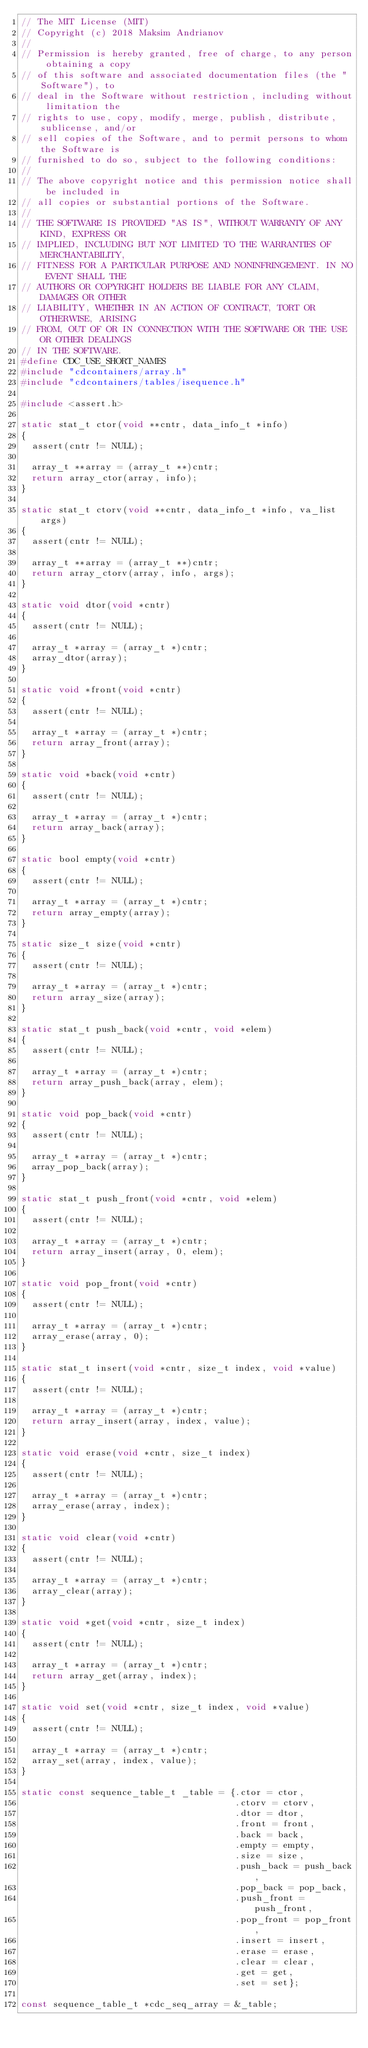Convert code to text. <code><loc_0><loc_0><loc_500><loc_500><_C_>// The MIT License (MIT)
// Copyright (c) 2018 Maksim Andrianov
//
// Permission is hereby granted, free of charge, to any person obtaining a copy
// of this software and associated documentation files (the "Software"), to
// deal in the Software without restriction, including without limitation the
// rights to use, copy, modify, merge, publish, distribute, sublicense, and/or
// sell copies of the Software, and to permit persons to whom the Software is
// furnished to do so, subject to the following conditions:
//
// The above copyright notice and this permission notice shall be included in
// all copies or substantial portions of the Software.
//
// THE SOFTWARE IS PROVIDED "AS IS", WITHOUT WARRANTY OF ANY KIND, EXPRESS OR
// IMPLIED, INCLUDING BUT NOT LIMITED TO THE WARRANTIES OF MERCHANTABILITY,
// FITNESS FOR A PARTICULAR PURPOSE AND NONINFRINGEMENT. IN NO EVENT SHALL THE
// AUTHORS OR COPYRIGHT HOLDERS BE LIABLE FOR ANY CLAIM, DAMAGES OR OTHER
// LIABILITY, WHETHER IN AN ACTION OF CONTRACT, TORT OR OTHERWISE, ARISING
// FROM, OUT OF OR IN CONNECTION WITH THE SOFTWARE OR THE USE OR OTHER DEALINGS
// IN THE SOFTWARE.
#define CDC_USE_SHORT_NAMES
#include "cdcontainers/array.h"
#include "cdcontainers/tables/isequence.h"

#include <assert.h>

static stat_t ctor(void **cntr, data_info_t *info)
{
  assert(cntr != NULL);

  array_t **array = (array_t **)cntr;
  return array_ctor(array, info);
}

static stat_t ctorv(void **cntr, data_info_t *info, va_list args)
{
  assert(cntr != NULL);

  array_t **array = (array_t **)cntr;
  return array_ctorv(array, info, args);
}

static void dtor(void *cntr)
{
  assert(cntr != NULL);

  array_t *array = (array_t *)cntr;
  array_dtor(array);
}

static void *front(void *cntr)
{
  assert(cntr != NULL);

  array_t *array = (array_t *)cntr;
  return array_front(array);
}

static void *back(void *cntr)
{
  assert(cntr != NULL);

  array_t *array = (array_t *)cntr;
  return array_back(array);
}

static bool empty(void *cntr)
{
  assert(cntr != NULL);

  array_t *array = (array_t *)cntr;
  return array_empty(array);
}

static size_t size(void *cntr)
{
  assert(cntr != NULL);

  array_t *array = (array_t *)cntr;
  return array_size(array);
}

static stat_t push_back(void *cntr, void *elem)
{
  assert(cntr != NULL);

  array_t *array = (array_t *)cntr;
  return array_push_back(array, elem);
}

static void pop_back(void *cntr)
{
  assert(cntr != NULL);

  array_t *array = (array_t *)cntr;
  array_pop_back(array);
}

static stat_t push_front(void *cntr, void *elem)
{
  assert(cntr != NULL);

  array_t *array = (array_t *)cntr;
  return array_insert(array, 0, elem);
}

static void pop_front(void *cntr)
{
  assert(cntr != NULL);

  array_t *array = (array_t *)cntr;
  array_erase(array, 0);
}

static stat_t insert(void *cntr, size_t index, void *value)
{
  assert(cntr != NULL);

  array_t *array = (array_t *)cntr;
  return array_insert(array, index, value);
}

static void erase(void *cntr, size_t index)
{
  assert(cntr != NULL);

  array_t *array = (array_t *)cntr;
  array_erase(array, index);
}

static void clear(void *cntr)
{
  assert(cntr != NULL);

  array_t *array = (array_t *)cntr;
  array_clear(array);
}

static void *get(void *cntr, size_t index)
{
  assert(cntr != NULL);

  array_t *array = (array_t *)cntr;
  return array_get(array, index);
}

static void set(void *cntr, size_t index, void *value)
{
  assert(cntr != NULL);

  array_t *array = (array_t *)cntr;
  array_set(array, index, value);
}

static const sequence_table_t _table = {.ctor = ctor,
                                        .ctorv = ctorv,
                                        .dtor = dtor,
                                        .front = front,
                                        .back = back,
                                        .empty = empty,
                                        .size = size,
                                        .push_back = push_back,
                                        .pop_back = pop_back,
                                        .push_front = push_front,
                                        .pop_front = pop_front,
                                        .insert = insert,
                                        .erase = erase,
                                        .clear = clear,
                                        .get = get,
                                        .set = set};

const sequence_table_t *cdc_seq_array = &_table;
</code> 